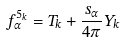Convert formula to latex. <formula><loc_0><loc_0><loc_500><loc_500>f ^ { 5 _ { k } } _ { \alpha } = T _ { k } + \frac { s _ { \alpha } } { 4 \pi } Y _ { k }</formula> 